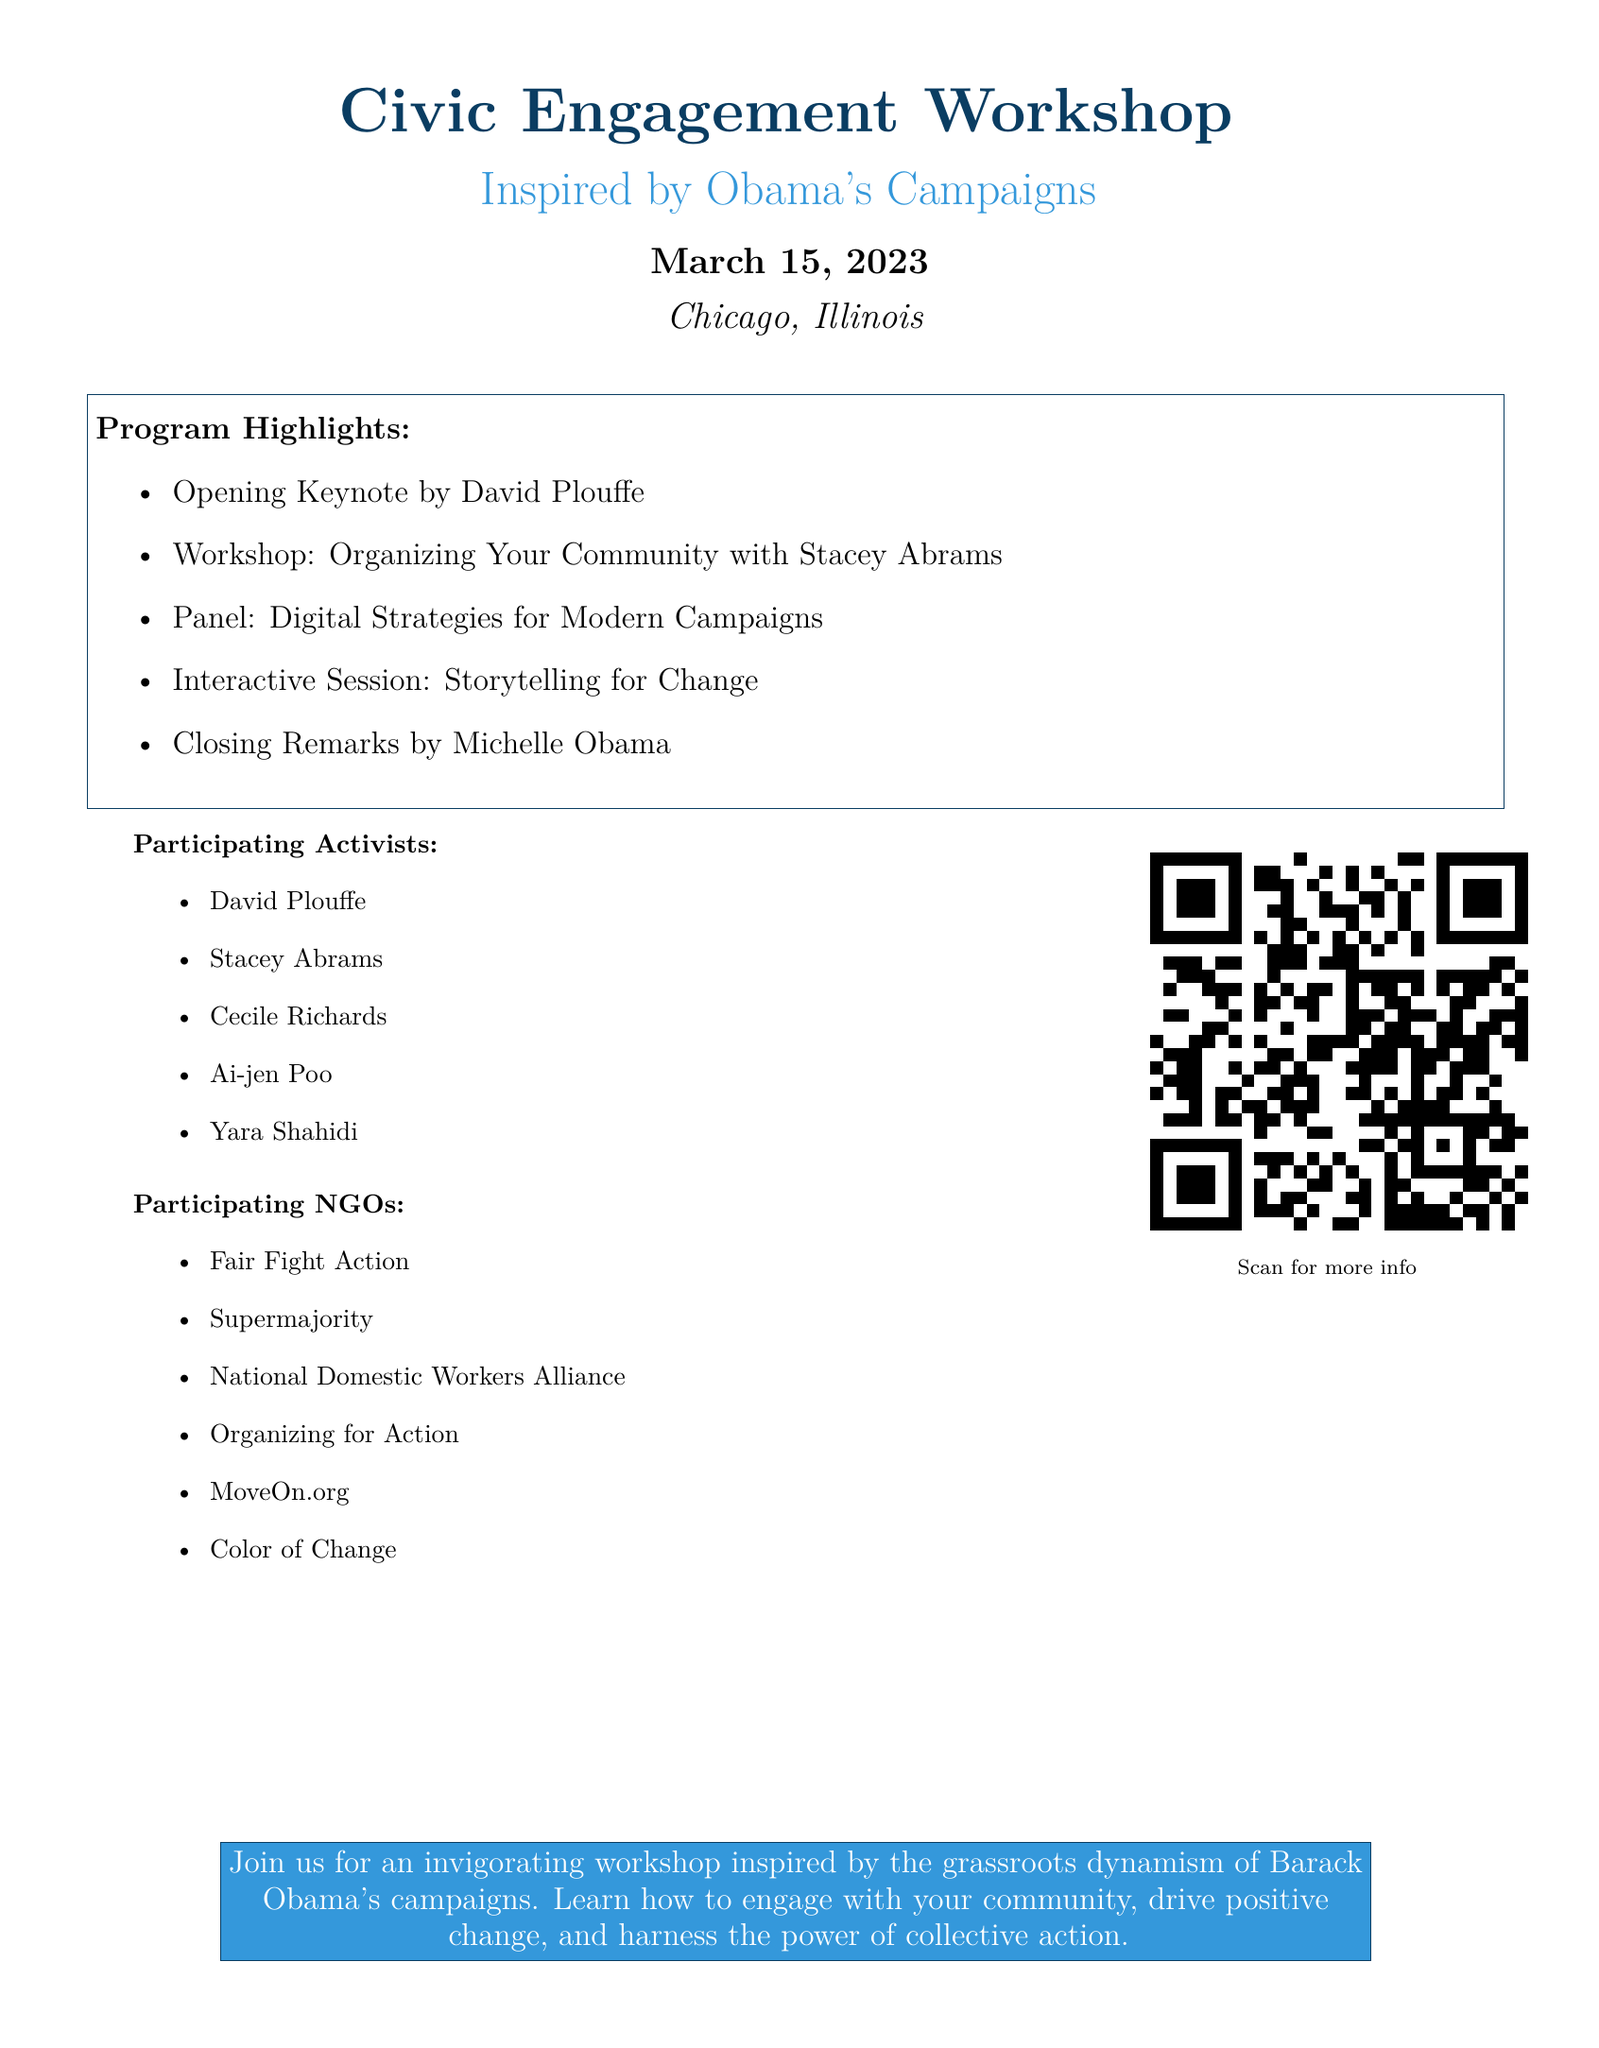What is the date of the workshop? The date of the workshop is mentioned at the beginning of the document.
Answer: March 15, 2023 Who is giving the opening keynote? The document specifies that David Plouffe will be giving the opening keynote.
Answer: David Plouffe How many participating NGOs are listed? The document lists six NGOs under the Participating NGOs section.
Answer: Six What is the name of the interactive session? The interactive session title is explicitly stated in the program highlights.
Answer: Storytelling for Change Which activist is noted for organizing community efforts? Stacey Abrams is mentioned as providing a workshop on organizing communities.
Answer: Stacey Abrams What color is identified as "obamablue" in the document? The specific color code for "obamablue" is provided in the document.
Answer: 0A3D62 Who gives the closing remarks? The document indicates that Michelle Obama will be providing the closing remarks.
Answer: Michelle Obama What is the main theme of the workshop? The main theme of the workshop is introduced in the concluding box about joining the workshop.
Answer: Grassroots dynamism What activity does the panel focus on? The document specifies the focus of the panel among the program highlights.
Answer: Digital Strategies for Modern Campaigns 